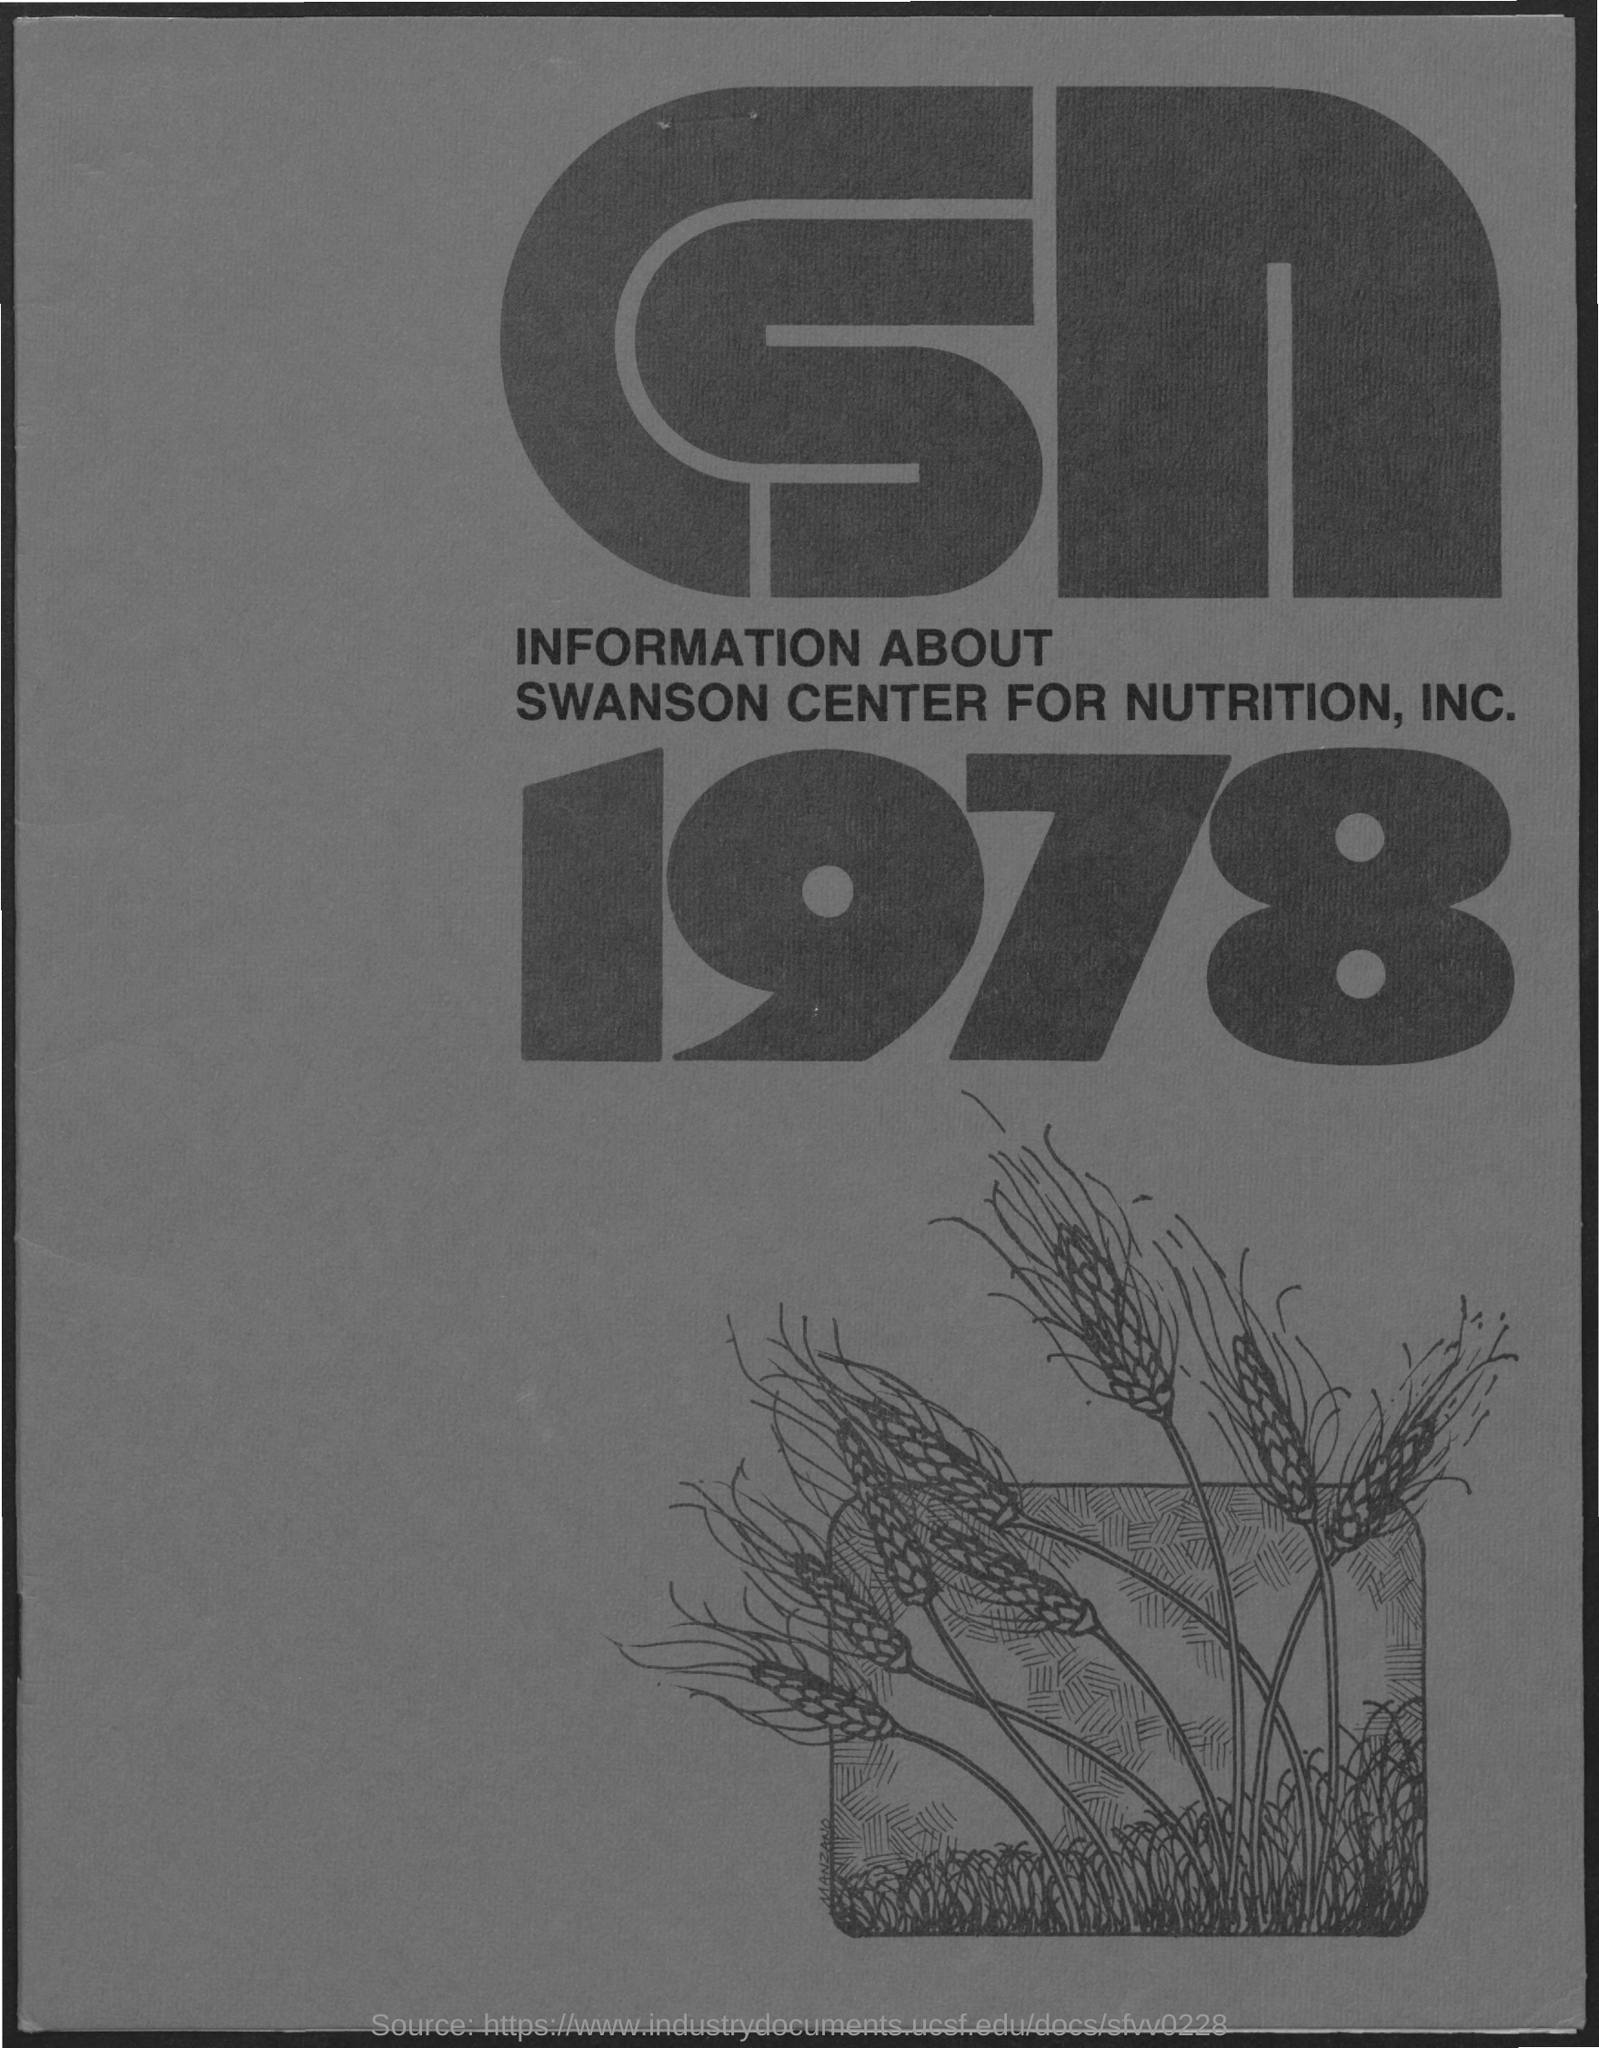What is the Information about?
Offer a very short reply. SWANSON CENTER FOR NUTRITION, INC. What is the Year?
Offer a terse response. 1978. 